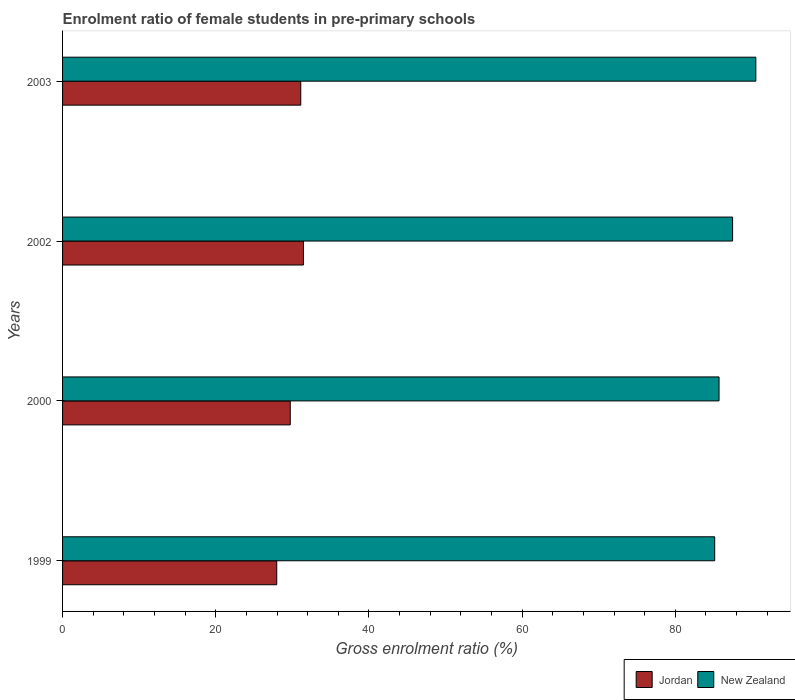Are the number of bars per tick equal to the number of legend labels?
Make the answer very short. Yes. Are the number of bars on each tick of the Y-axis equal?
Keep it short and to the point. Yes. How many bars are there on the 2nd tick from the top?
Ensure brevity in your answer.  2. How many bars are there on the 1st tick from the bottom?
Provide a short and direct response. 2. In how many cases, is the number of bars for a given year not equal to the number of legend labels?
Offer a very short reply. 0. What is the enrolment ratio of female students in pre-primary schools in New Zealand in 1999?
Offer a very short reply. 85.14. Across all years, what is the maximum enrolment ratio of female students in pre-primary schools in New Zealand?
Offer a very short reply. 90.52. Across all years, what is the minimum enrolment ratio of female students in pre-primary schools in Jordan?
Offer a very short reply. 27.96. What is the total enrolment ratio of female students in pre-primary schools in Jordan in the graph?
Provide a short and direct response. 120.25. What is the difference between the enrolment ratio of female students in pre-primary schools in Jordan in 1999 and that in 2003?
Your answer should be very brief. -3.14. What is the difference between the enrolment ratio of female students in pre-primary schools in New Zealand in 2000 and the enrolment ratio of female students in pre-primary schools in Jordan in 2002?
Your response must be concise. 54.26. What is the average enrolment ratio of female students in pre-primary schools in New Zealand per year?
Your answer should be very brief. 87.22. In the year 2002, what is the difference between the enrolment ratio of female students in pre-primary schools in Jordan and enrolment ratio of female students in pre-primary schools in New Zealand?
Make the answer very short. -56.03. What is the ratio of the enrolment ratio of female students in pre-primary schools in New Zealand in 1999 to that in 2002?
Give a very brief answer. 0.97. Is the enrolment ratio of female students in pre-primary schools in Jordan in 1999 less than that in 2003?
Offer a terse response. Yes. What is the difference between the highest and the second highest enrolment ratio of female students in pre-primary schools in Jordan?
Keep it short and to the point. 0.35. What is the difference between the highest and the lowest enrolment ratio of female students in pre-primary schools in New Zealand?
Your answer should be very brief. 5.37. In how many years, is the enrolment ratio of female students in pre-primary schools in Jordan greater than the average enrolment ratio of female students in pre-primary schools in Jordan taken over all years?
Give a very brief answer. 2. What does the 1st bar from the top in 1999 represents?
Keep it short and to the point. New Zealand. What does the 1st bar from the bottom in 2003 represents?
Keep it short and to the point. Jordan. How many bars are there?
Offer a terse response. 8. What is the difference between two consecutive major ticks on the X-axis?
Keep it short and to the point. 20. Does the graph contain any zero values?
Provide a short and direct response. No. Does the graph contain grids?
Your response must be concise. No. Where does the legend appear in the graph?
Give a very brief answer. Bottom right. How are the legend labels stacked?
Ensure brevity in your answer.  Horizontal. What is the title of the graph?
Provide a short and direct response. Enrolment ratio of female students in pre-primary schools. What is the label or title of the X-axis?
Your response must be concise. Gross enrolment ratio (%). What is the label or title of the Y-axis?
Ensure brevity in your answer.  Years. What is the Gross enrolment ratio (%) of Jordan in 1999?
Keep it short and to the point. 27.96. What is the Gross enrolment ratio (%) in New Zealand in 1999?
Provide a short and direct response. 85.14. What is the Gross enrolment ratio (%) in Jordan in 2000?
Provide a succinct answer. 29.73. What is the Gross enrolment ratio (%) in New Zealand in 2000?
Your response must be concise. 85.72. What is the Gross enrolment ratio (%) of Jordan in 2002?
Your answer should be very brief. 31.45. What is the Gross enrolment ratio (%) of New Zealand in 2002?
Give a very brief answer. 87.48. What is the Gross enrolment ratio (%) in Jordan in 2003?
Offer a very short reply. 31.1. What is the Gross enrolment ratio (%) in New Zealand in 2003?
Your response must be concise. 90.52. Across all years, what is the maximum Gross enrolment ratio (%) in Jordan?
Your answer should be compact. 31.45. Across all years, what is the maximum Gross enrolment ratio (%) in New Zealand?
Offer a terse response. 90.52. Across all years, what is the minimum Gross enrolment ratio (%) of Jordan?
Make the answer very short. 27.96. Across all years, what is the minimum Gross enrolment ratio (%) of New Zealand?
Give a very brief answer. 85.14. What is the total Gross enrolment ratio (%) in Jordan in the graph?
Your answer should be very brief. 120.25. What is the total Gross enrolment ratio (%) in New Zealand in the graph?
Give a very brief answer. 348.86. What is the difference between the Gross enrolment ratio (%) in Jordan in 1999 and that in 2000?
Provide a succinct answer. -1.76. What is the difference between the Gross enrolment ratio (%) of New Zealand in 1999 and that in 2000?
Give a very brief answer. -0.57. What is the difference between the Gross enrolment ratio (%) in Jordan in 1999 and that in 2002?
Offer a terse response. -3.49. What is the difference between the Gross enrolment ratio (%) in New Zealand in 1999 and that in 2002?
Your answer should be compact. -2.34. What is the difference between the Gross enrolment ratio (%) in Jordan in 1999 and that in 2003?
Provide a succinct answer. -3.14. What is the difference between the Gross enrolment ratio (%) of New Zealand in 1999 and that in 2003?
Make the answer very short. -5.37. What is the difference between the Gross enrolment ratio (%) of Jordan in 2000 and that in 2002?
Keep it short and to the point. -1.72. What is the difference between the Gross enrolment ratio (%) in New Zealand in 2000 and that in 2002?
Ensure brevity in your answer.  -1.77. What is the difference between the Gross enrolment ratio (%) of Jordan in 2000 and that in 2003?
Give a very brief answer. -1.37. What is the difference between the Gross enrolment ratio (%) in New Zealand in 2000 and that in 2003?
Your answer should be very brief. -4.8. What is the difference between the Gross enrolment ratio (%) in Jordan in 2002 and that in 2003?
Keep it short and to the point. 0.35. What is the difference between the Gross enrolment ratio (%) in New Zealand in 2002 and that in 2003?
Ensure brevity in your answer.  -3.03. What is the difference between the Gross enrolment ratio (%) in Jordan in 1999 and the Gross enrolment ratio (%) in New Zealand in 2000?
Provide a short and direct response. -57.75. What is the difference between the Gross enrolment ratio (%) in Jordan in 1999 and the Gross enrolment ratio (%) in New Zealand in 2002?
Ensure brevity in your answer.  -59.52. What is the difference between the Gross enrolment ratio (%) of Jordan in 1999 and the Gross enrolment ratio (%) of New Zealand in 2003?
Offer a very short reply. -62.55. What is the difference between the Gross enrolment ratio (%) in Jordan in 2000 and the Gross enrolment ratio (%) in New Zealand in 2002?
Provide a short and direct response. -57.75. What is the difference between the Gross enrolment ratio (%) of Jordan in 2000 and the Gross enrolment ratio (%) of New Zealand in 2003?
Your answer should be compact. -60.79. What is the difference between the Gross enrolment ratio (%) of Jordan in 2002 and the Gross enrolment ratio (%) of New Zealand in 2003?
Give a very brief answer. -59.07. What is the average Gross enrolment ratio (%) in Jordan per year?
Keep it short and to the point. 30.06. What is the average Gross enrolment ratio (%) in New Zealand per year?
Your answer should be compact. 87.22. In the year 1999, what is the difference between the Gross enrolment ratio (%) in Jordan and Gross enrolment ratio (%) in New Zealand?
Give a very brief answer. -57.18. In the year 2000, what is the difference between the Gross enrolment ratio (%) of Jordan and Gross enrolment ratio (%) of New Zealand?
Offer a terse response. -55.99. In the year 2002, what is the difference between the Gross enrolment ratio (%) of Jordan and Gross enrolment ratio (%) of New Zealand?
Provide a succinct answer. -56.03. In the year 2003, what is the difference between the Gross enrolment ratio (%) in Jordan and Gross enrolment ratio (%) in New Zealand?
Provide a succinct answer. -59.42. What is the ratio of the Gross enrolment ratio (%) of Jordan in 1999 to that in 2000?
Make the answer very short. 0.94. What is the ratio of the Gross enrolment ratio (%) in New Zealand in 1999 to that in 2000?
Ensure brevity in your answer.  0.99. What is the ratio of the Gross enrolment ratio (%) of Jordan in 1999 to that in 2002?
Your response must be concise. 0.89. What is the ratio of the Gross enrolment ratio (%) of New Zealand in 1999 to that in 2002?
Make the answer very short. 0.97. What is the ratio of the Gross enrolment ratio (%) in Jordan in 1999 to that in 2003?
Your answer should be compact. 0.9. What is the ratio of the Gross enrolment ratio (%) of New Zealand in 1999 to that in 2003?
Your response must be concise. 0.94. What is the ratio of the Gross enrolment ratio (%) of Jordan in 2000 to that in 2002?
Provide a succinct answer. 0.95. What is the ratio of the Gross enrolment ratio (%) of New Zealand in 2000 to that in 2002?
Provide a short and direct response. 0.98. What is the ratio of the Gross enrolment ratio (%) in Jordan in 2000 to that in 2003?
Ensure brevity in your answer.  0.96. What is the ratio of the Gross enrolment ratio (%) in New Zealand in 2000 to that in 2003?
Provide a short and direct response. 0.95. What is the ratio of the Gross enrolment ratio (%) of Jordan in 2002 to that in 2003?
Keep it short and to the point. 1.01. What is the ratio of the Gross enrolment ratio (%) in New Zealand in 2002 to that in 2003?
Your answer should be compact. 0.97. What is the difference between the highest and the second highest Gross enrolment ratio (%) in Jordan?
Your response must be concise. 0.35. What is the difference between the highest and the second highest Gross enrolment ratio (%) of New Zealand?
Offer a very short reply. 3.03. What is the difference between the highest and the lowest Gross enrolment ratio (%) of Jordan?
Offer a very short reply. 3.49. What is the difference between the highest and the lowest Gross enrolment ratio (%) of New Zealand?
Your answer should be compact. 5.37. 